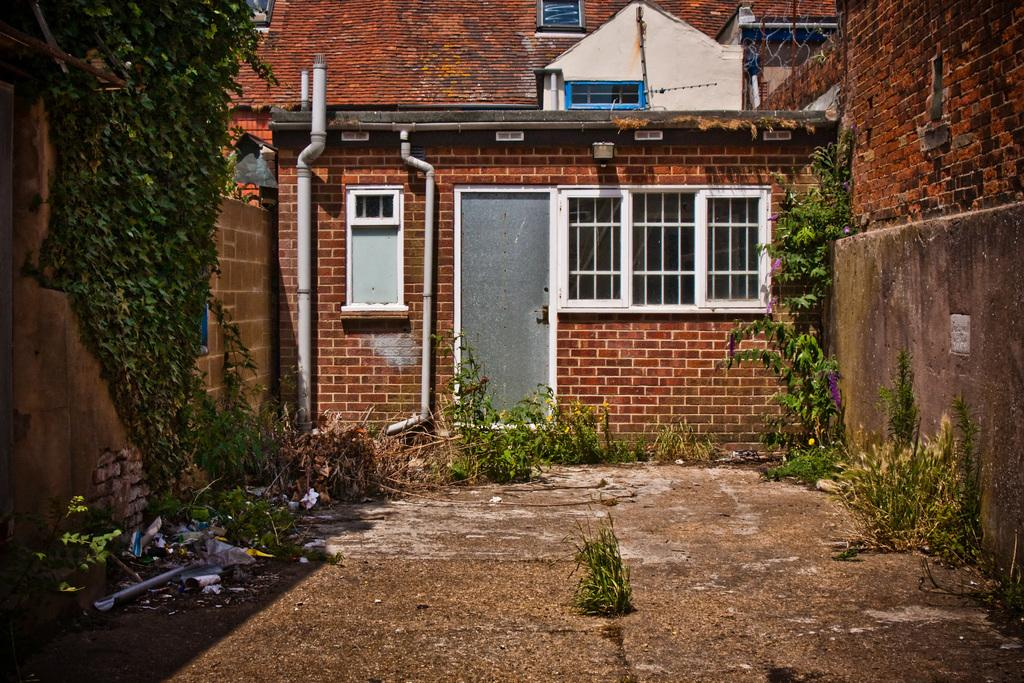What type of structure is visible in the image? There is a building in the image. Can you describe the entrance of the building? The building has a door in the middle. Are there any other openings in the building? Yes, there are windows on either side of the door. What can be seen near the front of the building? There are plants on either side of the wall in the front of the building. What type of apparatus is being used by the plants to communicate with each other in the image? There is no apparatus visible in the image, and the plants are not shown communicating with each other. 